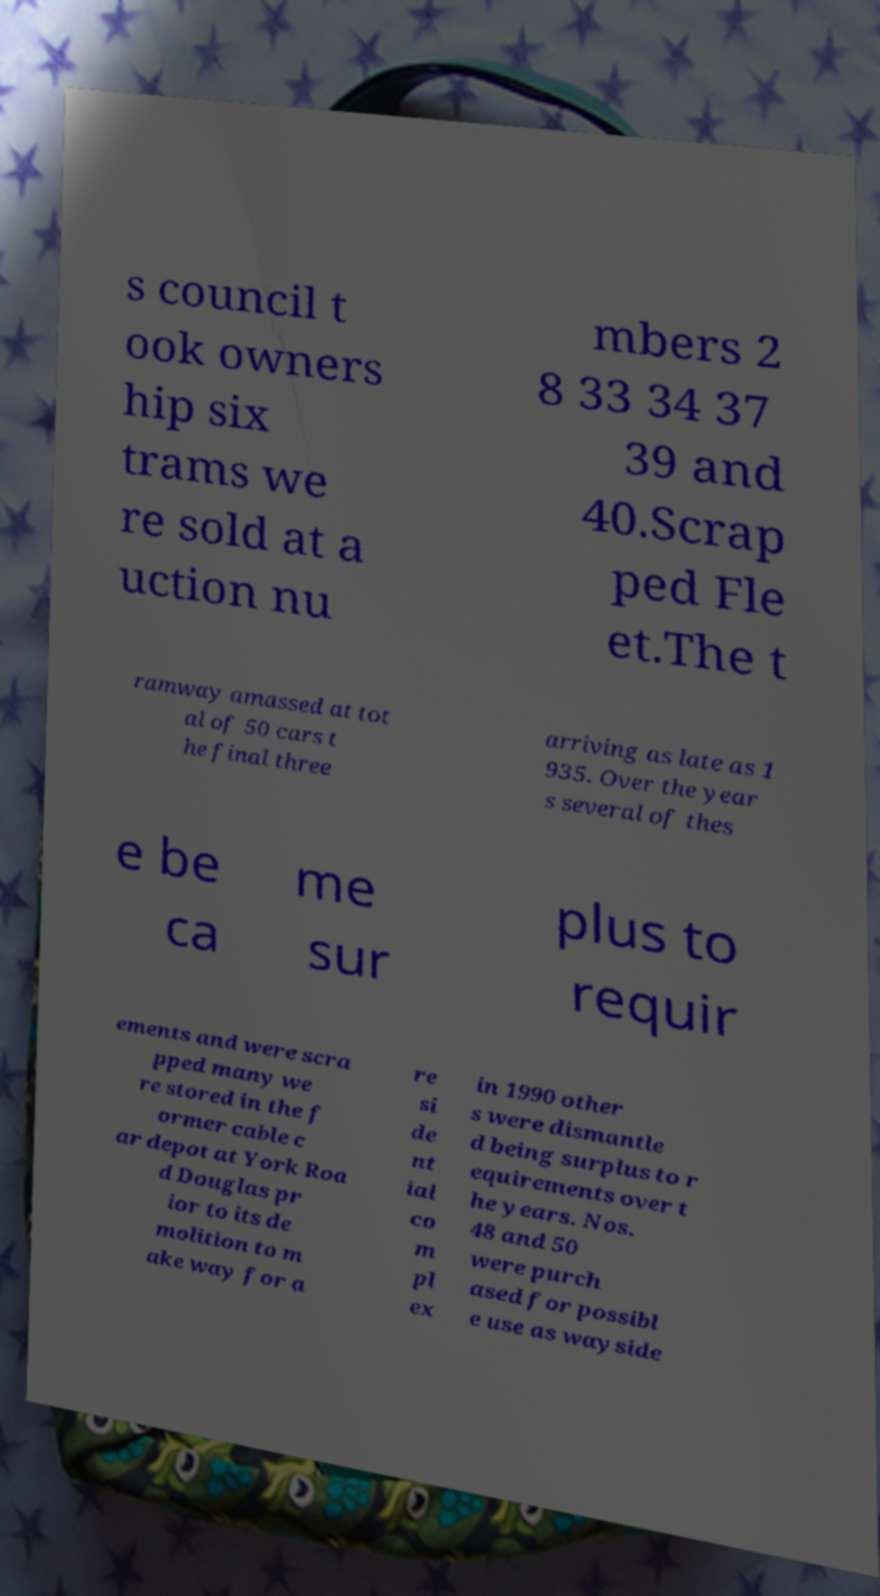Could you assist in decoding the text presented in this image and type it out clearly? s council t ook owners hip six trams we re sold at a uction nu mbers 2 8 33 34 37 39 and 40.Scrap ped Fle et.The t ramway amassed at tot al of 50 cars t he final three arriving as late as 1 935. Over the year s several of thes e be ca me sur plus to requir ements and were scra pped many we re stored in the f ormer cable c ar depot at York Roa d Douglas pr ior to its de molition to m ake way for a re si de nt ial co m pl ex in 1990 other s were dismantle d being surplus to r equirements over t he years. Nos. 48 and 50 were purch ased for possibl e use as wayside 